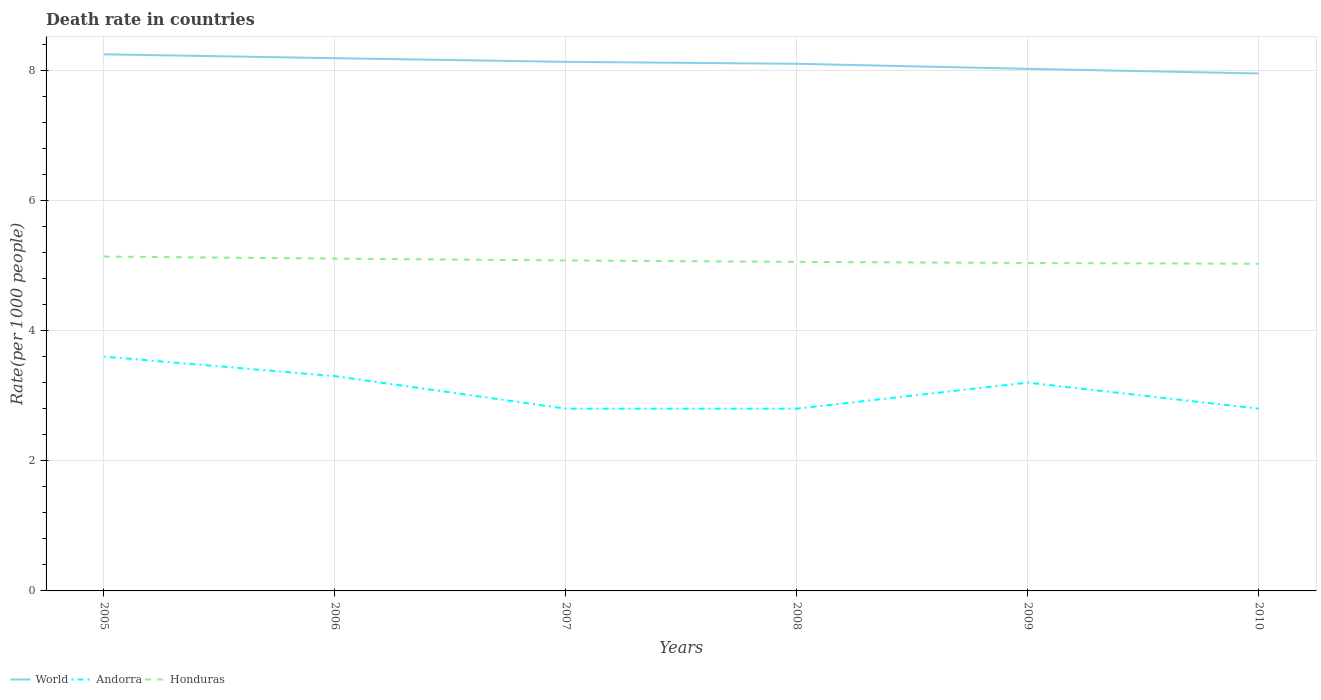Is the number of lines equal to the number of legend labels?
Give a very brief answer. Yes. Across all years, what is the maximum death rate in Andorra?
Your response must be concise. 2.8. What is the total death rate in Honduras in the graph?
Ensure brevity in your answer.  0.1. What is the difference between the highest and the second highest death rate in Andorra?
Keep it short and to the point. 0.8. What is the difference between the highest and the lowest death rate in World?
Offer a very short reply. 3. What is the difference between two consecutive major ticks on the Y-axis?
Offer a terse response. 2. Where does the legend appear in the graph?
Keep it short and to the point. Bottom left. How many legend labels are there?
Provide a succinct answer. 3. What is the title of the graph?
Give a very brief answer. Death rate in countries. What is the label or title of the X-axis?
Offer a very short reply. Years. What is the label or title of the Y-axis?
Offer a terse response. Rate(per 1000 people). What is the Rate(per 1000 people) in World in 2005?
Provide a short and direct response. 8.24. What is the Rate(per 1000 people) of Honduras in 2005?
Offer a terse response. 5.14. What is the Rate(per 1000 people) of World in 2006?
Provide a succinct answer. 8.18. What is the Rate(per 1000 people) of Honduras in 2006?
Give a very brief answer. 5.11. What is the Rate(per 1000 people) in World in 2007?
Offer a terse response. 8.13. What is the Rate(per 1000 people) in Honduras in 2007?
Make the answer very short. 5.08. What is the Rate(per 1000 people) of World in 2008?
Provide a short and direct response. 8.1. What is the Rate(per 1000 people) in Honduras in 2008?
Offer a very short reply. 5.05. What is the Rate(per 1000 people) of World in 2009?
Keep it short and to the point. 8.02. What is the Rate(per 1000 people) in Honduras in 2009?
Make the answer very short. 5.04. What is the Rate(per 1000 people) of World in 2010?
Provide a succinct answer. 7.95. What is the Rate(per 1000 people) of Andorra in 2010?
Make the answer very short. 2.8. What is the Rate(per 1000 people) in Honduras in 2010?
Your response must be concise. 5.03. Across all years, what is the maximum Rate(per 1000 people) in World?
Your answer should be compact. 8.24. Across all years, what is the maximum Rate(per 1000 people) of Andorra?
Ensure brevity in your answer.  3.6. Across all years, what is the maximum Rate(per 1000 people) in Honduras?
Give a very brief answer. 5.14. Across all years, what is the minimum Rate(per 1000 people) in World?
Make the answer very short. 7.95. Across all years, what is the minimum Rate(per 1000 people) in Honduras?
Offer a terse response. 5.03. What is the total Rate(per 1000 people) in World in the graph?
Provide a short and direct response. 48.62. What is the total Rate(per 1000 people) of Andorra in the graph?
Your answer should be compact. 18.5. What is the total Rate(per 1000 people) in Honduras in the graph?
Your answer should be compact. 30.44. What is the difference between the Rate(per 1000 people) in World in 2005 and that in 2006?
Your answer should be compact. 0.06. What is the difference between the Rate(per 1000 people) in Andorra in 2005 and that in 2006?
Offer a very short reply. 0.3. What is the difference between the Rate(per 1000 people) of Honduras in 2005 and that in 2006?
Ensure brevity in your answer.  0.03. What is the difference between the Rate(per 1000 people) of World in 2005 and that in 2007?
Provide a short and direct response. 0.12. What is the difference between the Rate(per 1000 people) in World in 2005 and that in 2008?
Give a very brief answer. 0.15. What is the difference between the Rate(per 1000 people) in Honduras in 2005 and that in 2008?
Offer a terse response. 0.08. What is the difference between the Rate(per 1000 people) of World in 2005 and that in 2009?
Your answer should be compact. 0.22. What is the difference between the Rate(per 1000 people) of Honduras in 2005 and that in 2009?
Provide a succinct answer. 0.1. What is the difference between the Rate(per 1000 people) of World in 2005 and that in 2010?
Your response must be concise. 0.29. What is the difference between the Rate(per 1000 people) of Andorra in 2005 and that in 2010?
Provide a short and direct response. 0.8. What is the difference between the Rate(per 1000 people) in Honduras in 2005 and that in 2010?
Keep it short and to the point. 0.11. What is the difference between the Rate(per 1000 people) in World in 2006 and that in 2007?
Your response must be concise. 0.06. What is the difference between the Rate(per 1000 people) of Andorra in 2006 and that in 2007?
Your answer should be very brief. 0.5. What is the difference between the Rate(per 1000 people) in Honduras in 2006 and that in 2007?
Your response must be concise. 0.03. What is the difference between the Rate(per 1000 people) of World in 2006 and that in 2008?
Make the answer very short. 0.09. What is the difference between the Rate(per 1000 people) in Andorra in 2006 and that in 2008?
Keep it short and to the point. 0.5. What is the difference between the Rate(per 1000 people) in Honduras in 2006 and that in 2008?
Offer a terse response. 0.05. What is the difference between the Rate(per 1000 people) of World in 2006 and that in 2009?
Provide a short and direct response. 0.16. What is the difference between the Rate(per 1000 people) of Honduras in 2006 and that in 2009?
Provide a succinct answer. 0.07. What is the difference between the Rate(per 1000 people) of World in 2006 and that in 2010?
Your answer should be very brief. 0.23. What is the difference between the Rate(per 1000 people) of Andorra in 2006 and that in 2010?
Your response must be concise. 0.5. What is the difference between the Rate(per 1000 people) of Honduras in 2006 and that in 2010?
Offer a terse response. 0.08. What is the difference between the Rate(per 1000 people) in World in 2007 and that in 2008?
Your response must be concise. 0.03. What is the difference between the Rate(per 1000 people) of Honduras in 2007 and that in 2008?
Your response must be concise. 0.02. What is the difference between the Rate(per 1000 people) of World in 2007 and that in 2009?
Provide a short and direct response. 0.11. What is the difference between the Rate(per 1000 people) of Honduras in 2007 and that in 2009?
Offer a very short reply. 0.04. What is the difference between the Rate(per 1000 people) in World in 2007 and that in 2010?
Provide a short and direct response. 0.18. What is the difference between the Rate(per 1000 people) in Andorra in 2007 and that in 2010?
Make the answer very short. 0. What is the difference between the Rate(per 1000 people) in Honduras in 2007 and that in 2010?
Ensure brevity in your answer.  0.05. What is the difference between the Rate(per 1000 people) in World in 2008 and that in 2009?
Provide a short and direct response. 0.08. What is the difference between the Rate(per 1000 people) of Honduras in 2008 and that in 2009?
Offer a very short reply. 0.02. What is the difference between the Rate(per 1000 people) of World in 2008 and that in 2010?
Keep it short and to the point. 0.15. What is the difference between the Rate(per 1000 people) in Honduras in 2008 and that in 2010?
Ensure brevity in your answer.  0.03. What is the difference between the Rate(per 1000 people) of World in 2009 and that in 2010?
Your answer should be compact. 0.07. What is the difference between the Rate(per 1000 people) in Andorra in 2009 and that in 2010?
Your answer should be compact. 0.4. What is the difference between the Rate(per 1000 people) of Honduras in 2009 and that in 2010?
Provide a succinct answer. 0.01. What is the difference between the Rate(per 1000 people) in World in 2005 and the Rate(per 1000 people) in Andorra in 2006?
Ensure brevity in your answer.  4.94. What is the difference between the Rate(per 1000 people) of World in 2005 and the Rate(per 1000 people) of Honduras in 2006?
Offer a very short reply. 3.14. What is the difference between the Rate(per 1000 people) in Andorra in 2005 and the Rate(per 1000 people) in Honduras in 2006?
Your answer should be compact. -1.5. What is the difference between the Rate(per 1000 people) of World in 2005 and the Rate(per 1000 people) of Andorra in 2007?
Provide a short and direct response. 5.44. What is the difference between the Rate(per 1000 people) in World in 2005 and the Rate(per 1000 people) in Honduras in 2007?
Your answer should be very brief. 3.17. What is the difference between the Rate(per 1000 people) in Andorra in 2005 and the Rate(per 1000 people) in Honduras in 2007?
Your answer should be compact. -1.48. What is the difference between the Rate(per 1000 people) of World in 2005 and the Rate(per 1000 people) of Andorra in 2008?
Your response must be concise. 5.44. What is the difference between the Rate(per 1000 people) of World in 2005 and the Rate(per 1000 people) of Honduras in 2008?
Keep it short and to the point. 3.19. What is the difference between the Rate(per 1000 people) in Andorra in 2005 and the Rate(per 1000 people) in Honduras in 2008?
Offer a terse response. -1.46. What is the difference between the Rate(per 1000 people) of World in 2005 and the Rate(per 1000 people) of Andorra in 2009?
Your answer should be very brief. 5.04. What is the difference between the Rate(per 1000 people) in World in 2005 and the Rate(per 1000 people) in Honduras in 2009?
Offer a terse response. 3.21. What is the difference between the Rate(per 1000 people) in Andorra in 2005 and the Rate(per 1000 people) in Honduras in 2009?
Provide a succinct answer. -1.44. What is the difference between the Rate(per 1000 people) in World in 2005 and the Rate(per 1000 people) in Andorra in 2010?
Offer a very short reply. 5.44. What is the difference between the Rate(per 1000 people) in World in 2005 and the Rate(per 1000 people) in Honduras in 2010?
Provide a succinct answer. 3.22. What is the difference between the Rate(per 1000 people) of Andorra in 2005 and the Rate(per 1000 people) of Honduras in 2010?
Your answer should be very brief. -1.43. What is the difference between the Rate(per 1000 people) in World in 2006 and the Rate(per 1000 people) in Andorra in 2007?
Give a very brief answer. 5.38. What is the difference between the Rate(per 1000 people) in World in 2006 and the Rate(per 1000 people) in Honduras in 2007?
Make the answer very short. 3.11. What is the difference between the Rate(per 1000 people) of Andorra in 2006 and the Rate(per 1000 people) of Honduras in 2007?
Offer a very short reply. -1.78. What is the difference between the Rate(per 1000 people) in World in 2006 and the Rate(per 1000 people) in Andorra in 2008?
Make the answer very short. 5.38. What is the difference between the Rate(per 1000 people) of World in 2006 and the Rate(per 1000 people) of Honduras in 2008?
Your answer should be very brief. 3.13. What is the difference between the Rate(per 1000 people) of Andorra in 2006 and the Rate(per 1000 people) of Honduras in 2008?
Provide a short and direct response. -1.75. What is the difference between the Rate(per 1000 people) of World in 2006 and the Rate(per 1000 people) of Andorra in 2009?
Give a very brief answer. 4.98. What is the difference between the Rate(per 1000 people) in World in 2006 and the Rate(per 1000 people) in Honduras in 2009?
Provide a short and direct response. 3.15. What is the difference between the Rate(per 1000 people) of Andorra in 2006 and the Rate(per 1000 people) of Honduras in 2009?
Offer a terse response. -1.74. What is the difference between the Rate(per 1000 people) in World in 2006 and the Rate(per 1000 people) in Andorra in 2010?
Offer a very short reply. 5.38. What is the difference between the Rate(per 1000 people) in World in 2006 and the Rate(per 1000 people) in Honduras in 2010?
Provide a short and direct response. 3.16. What is the difference between the Rate(per 1000 people) in Andorra in 2006 and the Rate(per 1000 people) in Honduras in 2010?
Your answer should be very brief. -1.73. What is the difference between the Rate(per 1000 people) of World in 2007 and the Rate(per 1000 people) of Andorra in 2008?
Provide a short and direct response. 5.33. What is the difference between the Rate(per 1000 people) of World in 2007 and the Rate(per 1000 people) of Honduras in 2008?
Give a very brief answer. 3.07. What is the difference between the Rate(per 1000 people) of Andorra in 2007 and the Rate(per 1000 people) of Honduras in 2008?
Provide a succinct answer. -2.25. What is the difference between the Rate(per 1000 people) of World in 2007 and the Rate(per 1000 people) of Andorra in 2009?
Provide a succinct answer. 4.93. What is the difference between the Rate(per 1000 people) of World in 2007 and the Rate(per 1000 people) of Honduras in 2009?
Your response must be concise. 3.09. What is the difference between the Rate(per 1000 people) of Andorra in 2007 and the Rate(per 1000 people) of Honduras in 2009?
Offer a terse response. -2.24. What is the difference between the Rate(per 1000 people) in World in 2007 and the Rate(per 1000 people) in Andorra in 2010?
Your response must be concise. 5.33. What is the difference between the Rate(per 1000 people) of World in 2007 and the Rate(per 1000 people) of Honduras in 2010?
Give a very brief answer. 3.1. What is the difference between the Rate(per 1000 people) in Andorra in 2007 and the Rate(per 1000 people) in Honduras in 2010?
Make the answer very short. -2.23. What is the difference between the Rate(per 1000 people) of World in 2008 and the Rate(per 1000 people) of Andorra in 2009?
Your answer should be compact. 4.9. What is the difference between the Rate(per 1000 people) of World in 2008 and the Rate(per 1000 people) of Honduras in 2009?
Ensure brevity in your answer.  3.06. What is the difference between the Rate(per 1000 people) in Andorra in 2008 and the Rate(per 1000 people) in Honduras in 2009?
Make the answer very short. -2.24. What is the difference between the Rate(per 1000 people) of World in 2008 and the Rate(per 1000 people) of Andorra in 2010?
Your answer should be compact. 5.3. What is the difference between the Rate(per 1000 people) of World in 2008 and the Rate(per 1000 people) of Honduras in 2010?
Make the answer very short. 3.07. What is the difference between the Rate(per 1000 people) of Andorra in 2008 and the Rate(per 1000 people) of Honduras in 2010?
Your answer should be compact. -2.23. What is the difference between the Rate(per 1000 people) in World in 2009 and the Rate(per 1000 people) in Andorra in 2010?
Your answer should be very brief. 5.22. What is the difference between the Rate(per 1000 people) of World in 2009 and the Rate(per 1000 people) of Honduras in 2010?
Ensure brevity in your answer.  2.99. What is the difference between the Rate(per 1000 people) of Andorra in 2009 and the Rate(per 1000 people) of Honduras in 2010?
Provide a short and direct response. -1.83. What is the average Rate(per 1000 people) of World per year?
Make the answer very short. 8.1. What is the average Rate(per 1000 people) in Andorra per year?
Provide a short and direct response. 3.08. What is the average Rate(per 1000 people) of Honduras per year?
Keep it short and to the point. 5.07. In the year 2005, what is the difference between the Rate(per 1000 people) of World and Rate(per 1000 people) of Andorra?
Your answer should be compact. 4.64. In the year 2005, what is the difference between the Rate(per 1000 people) in World and Rate(per 1000 people) in Honduras?
Offer a terse response. 3.11. In the year 2005, what is the difference between the Rate(per 1000 people) in Andorra and Rate(per 1000 people) in Honduras?
Offer a terse response. -1.54. In the year 2006, what is the difference between the Rate(per 1000 people) in World and Rate(per 1000 people) in Andorra?
Your answer should be very brief. 4.88. In the year 2006, what is the difference between the Rate(per 1000 people) in World and Rate(per 1000 people) in Honduras?
Offer a terse response. 3.08. In the year 2006, what is the difference between the Rate(per 1000 people) in Andorra and Rate(per 1000 people) in Honduras?
Provide a succinct answer. -1.8. In the year 2007, what is the difference between the Rate(per 1000 people) in World and Rate(per 1000 people) in Andorra?
Give a very brief answer. 5.33. In the year 2007, what is the difference between the Rate(per 1000 people) in World and Rate(per 1000 people) in Honduras?
Offer a terse response. 3.05. In the year 2007, what is the difference between the Rate(per 1000 people) of Andorra and Rate(per 1000 people) of Honduras?
Ensure brevity in your answer.  -2.28. In the year 2008, what is the difference between the Rate(per 1000 people) of World and Rate(per 1000 people) of Andorra?
Ensure brevity in your answer.  5.3. In the year 2008, what is the difference between the Rate(per 1000 people) in World and Rate(per 1000 people) in Honduras?
Offer a very short reply. 3.04. In the year 2008, what is the difference between the Rate(per 1000 people) of Andorra and Rate(per 1000 people) of Honduras?
Offer a very short reply. -2.25. In the year 2009, what is the difference between the Rate(per 1000 people) in World and Rate(per 1000 people) in Andorra?
Ensure brevity in your answer.  4.82. In the year 2009, what is the difference between the Rate(per 1000 people) in World and Rate(per 1000 people) in Honduras?
Give a very brief answer. 2.98. In the year 2009, what is the difference between the Rate(per 1000 people) of Andorra and Rate(per 1000 people) of Honduras?
Your answer should be compact. -1.84. In the year 2010, what is the difference between the Rate(per 1000 people) in World and Rate(per 1000 people) in Andorra?
Ensure brevity in your answer.  5.15. In the year 2010, what is the difference between the Rate(per 1000 people) of World and Rate(per 1000 people) of Honduras?
Your answer should be very brief. 2.92. In the year 2010, what is the difference between the Rate(per 1000 people) in Andorra and Rate(per 1000 people) in Honduras?
Keep it short and to the point. -2.23. What is the ratio of the Rate(per 1000 people) in World in 2005 to that in 2006?
Your response must be concise. 1.01. What is the ratio of the Rate(per 1000 people) of Andorra in 2005 to that in 2006?
Keep it short and to the point. 1.09. What is the ratio of the Rate(per 1000 people) of World in 2005 to that in 2007?
Offer a very short reply. 1.01. What is the ratio of the Rate(per 1000 people) in Andorra in 2005 to that in 2007?
Keep it short and to the point. 1.29. What is the ratio of the Rate(per 1000 people) of Honduras in 2005 to that in 2007?
Your answer should be compact. 1.01. What is the ratio of the Rate(per 1000 people) of World in 2005 to that in 2008?
Give a very brief answer. 1.02. What is the ratio of the Rate(per 1000 people) of Honduras in 2005 to that in 2008?
Provide a short and direct response. 1.02. What is the ratio of the Rate(per 1000 people) in World in 2005 to that in 2009?
Keep it short and to the point. 1.03. What is the ratio of the Rate(per 1000 people) in Andorra in 2005 to that in 2009?
Offer a terse response. 1.12. What is the ratio of the Rate(per 1000 people) in Honduras in 2005 to that in 2009?
Make the answer very short. 1.02. What is the ratio of the Rate(per 1000 people) of World in 2005 to that in 2010?
Provide a short and direct response. 1.04. What is the ratio of the Rate(per 1000 people) in Honduras in 2005 to that in 2010?
Keep it short and to the point. 1.02. What is the ratio of the Rate(per 1000 people) of World in 2006 to that in 2007?
Offer a terse response. 1.01. What is the ratio of the Rate(per 1000 people) in Andorra in 2006 to that in 2007?
Keep it short and to the point. 1.18. What is the ratio of the Rate(per 1000 people) of World in 2006 to that in 2008?
Provide a short and direct response. 1.01. What is the ratio of the Rate(per 1000 people) of Andorra in 2006 to that in 2008?
Offer a terse response. 1.18. What is the ratio of the Rate(per 1000 people) of Honduras in 2006 to that in 2008?
Your answer should be compact. 1.01. What is the ratio of the Rate(per 1000 people) of World in 2006 to that in 2009?
Your answer should be very brief. 1.02. What is the ratio of the Rate(per 1000 people) of Andorra in 2006 to that in 2009?
Make the answer very short. 1.03. What is the ratio of the Rate(per 1000 people) of Honduras in 2006 to that in 2009?
Make the answer very short. 1.01. What is the ratio of the Rate(per 1000 people) in World in 2006 to that in 2010?
Your answer should be very brief. 1.03. What is the ratio of the Rate(per 1000 people) in Andorra in 2006 to that in 2010?
Ensure brevity in your answer.  1.18. What is the ratio of the Rate(per 1000 people) of Honduras in 2006 to that in 2010?
Your answer should be compact. 1.02. What is the ratio of the Rate(per 1000 people) of Andorra in 2007 to that in 2008?
Make the answer very short. 1. What is the ratio of the Rate(per 1000 people) in World in 2007 to that in 2009?
Provide a short and direct response. 1.01. What is the ratio of the Rate(per 1000 people) of Andorra in 2007 to that in 2009?
Provide a short and direct response. 0.88. What is the ratio of the Rate(per 1000 people) in Honduras in 2007 to that in 2009?
Your response must be concise. 1.01. What is the ratio of the Rate(per 1000 people) of World in 2007 to that in 2010?
Keep it short and to the point. 1.02. What is the ratio of the Rate(per 1000 people) of Andorra in 2007 to that in 2010?
Your answer should be compact. 1. What is the ratio of the Rate(per 1000 people) of World in 2008 to that in 2009?
Provide a succinct answer. 1.01. What is the ratio of the Rate(per 1000 people) in Andorra in 2008 to that in 2009?
Offer a terse response. 0.88. What is the ratio of the Rate(per 1000 people) of World in 2008 to that in 2010?
Ensure brevity in your answer.  1.02. What is the ratio of the Rate(per 1000 people) of World in 2009 to that in 2010?
Provide a short and direct response. 1.01. What is the ratio of the Rate(per 1000 people) in Andorra in 2009 to that in 2010?
Provide a succinct answer. 1.14. What is the ratio of the Rate(per 1000 people) of Honduras in 2009 to that in 2010?
Make the answer very short. 1. What is the difference between the highest and the second highest Rate(per 1000 people) of World?
Your answer should be compact. 0.06. What is the difference between the highest and the second highest Rate(per 1000 people) of Honduras?
Provide a succinct answer. 0.03. What is the difference between the highest and the lowest Rate(per 1000 people) of World?
Keep it short and to the point. 0.29. What is the difference between the highest and the lowest Rate(per 1000 people) of Andorra?
Your answer should be compact. 0.8. What is the difference between the highest and the lowest Rate(per 1000 people) in Honduras?
Make the answer very short. 0.11. 